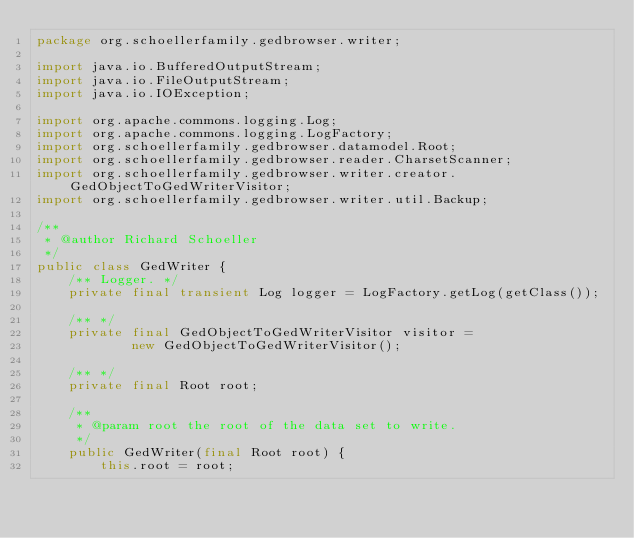Convert code to text. <code><loc_0><loc_0><loc_500><loc_500><_Java_>package org.schoellerfamily.gedbrowser.writer;

import java.io.BufferedOutputStream;
import java.io.FileOutputStream;
import java.io.IOException;

import org.apache.commons.logging.Log;
import org.apache.commons.logging.LogFactory;
import org.schoellerfamily.gedbrowser.datamodel.Root;
import org.schoellerfamily.gedbrowser.reader.CharsetScanner;
import org.schoellerfamily.gedbrowser.writer.creator.GedObjectToGedWriterVisitor;
import org.schoellerfamily.gedbrowser.writer.util.Backup;

/**
 * @author Richard Schoeller
 */
public class GedWriter {
    /** Logger. */
    private final transient Log logger = LogFactory.getLog(getClass());

    /** */
    private final GedObjectToGedWriterVisitor visitor =
            new GedObjectToGedWriterVisitor();

    /** */
    private final Root root;

    /**
     * @param root the root of the data set to write.
     */
    public GedWriter(final Root root) {
        this.root = root;</code> 